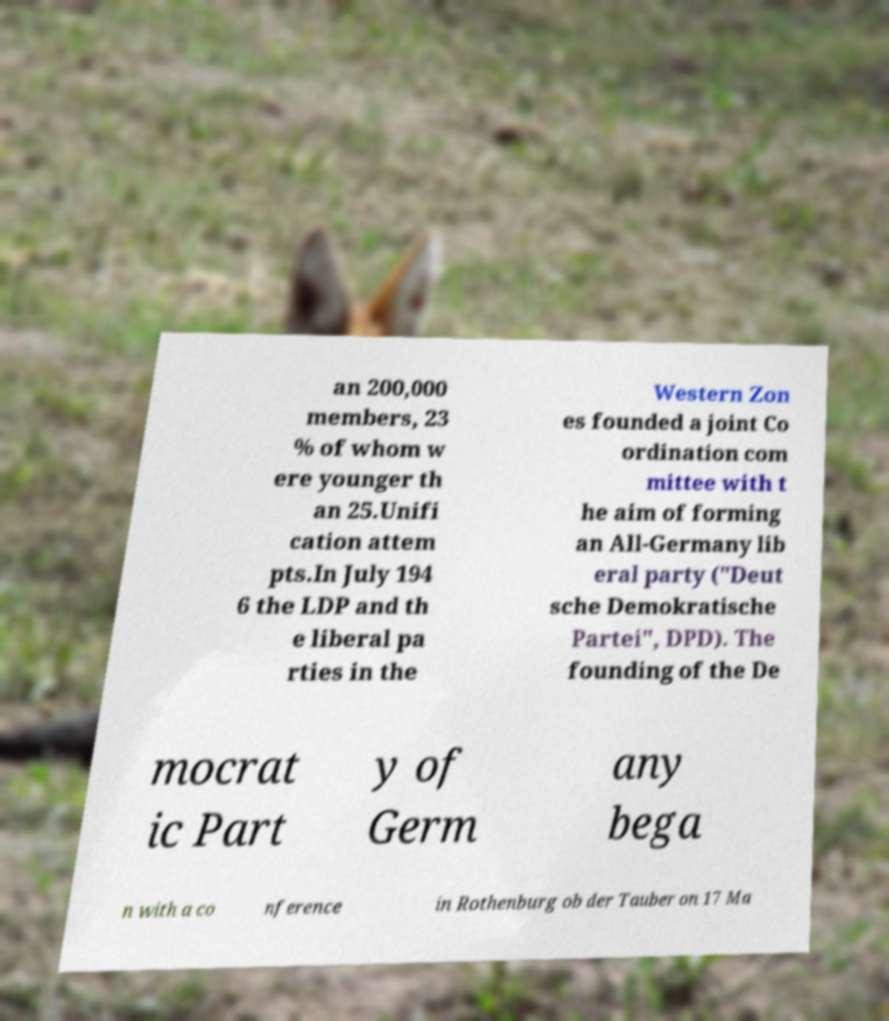Can you accurately transcribe the text from the provided image for me? an 200,000 members, 23 % of whom w ere younger th an 25.Unifi cation attem pts.In July 194 6 the LDP and th e liberal pa rties in the Western Zon es founded a joint Co ordination com mittee with t he aim of forming an All-Germany lib eral party ("Deut sche Demokratische Partei", DPD). The founding of the De mocrat ic Part y of Germ any bega n with a co nference in Rothenburg ob der Tauber on 17 Ma 